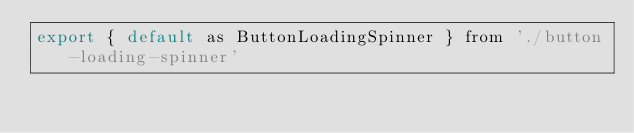<code> <loc_0><loc_0><loc_500><loc_500><_JavaScript_>export { default as ButtonLoadingSpinner } from './button-loading-spinner'</code> 